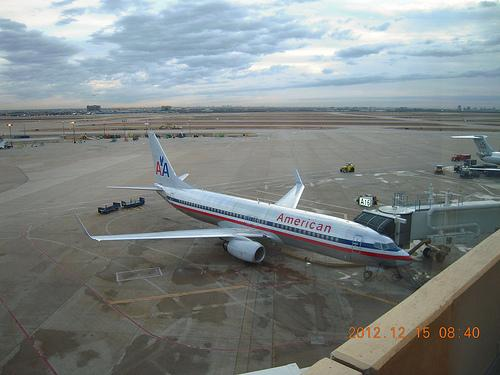What is the function of the lights on the edge of the tarmac? The lights on the edge of the tarmac help in guiding the aircraft and airport operations during low visibility conditions and nighttime. What sentiment can be evoked from the image due to the weather conditions? A slightly gloomy or dreary sentiment might be evoked due to the cloudy and overcast day. Mention one specific detail about the airplane's appearance. The airplane is silver and has the American Airlines logo. Count the number of luggage carriers mentioned in the image. There are two luggage carriers mentioned in the image. Describe the weather and time of day indicated in the image. It is a cloudy overcast day on a December morning. Describe a specific vehicle that's related to luggage in the scene. Luggage loading vehicle is present in the scene. What type of vehicle is the main focus of the image? An airplane is the main focus of the image. Identify one object used by passengers to board the plane. There is a temporary corridor to load passengers into the plane. How many times was the airplane described as silver? The airplane was described as silver once. Identify an object or area that appears to be elevated above the tarmac. There is an elevated area above the tarmac in the image. Can you identify the flock of birds flying above the airplane in the top-right corner? There is no flock of birds flying above the airplane in the top-right corner. Which monument can be seen in the background behind the airplane? There is no prominent monument visible in the background behind the airplane. Can you find the helicopter hovering above the tarmac? There is no helicopter hovering above the tarmac. Where is the hot air balloon floating in the sky near the airplane? There is no hot air balloon floating in the sky near the airplane. Find the group of people standing next to the temporary corridor to load passengers into the plane. There is no group of people standing next to the temporary corridor to load passengers into the plane. Where is the pilot of the airplane waving from the cockpit window? The pilot of the airplane is not visible waving from the cockpit window. 